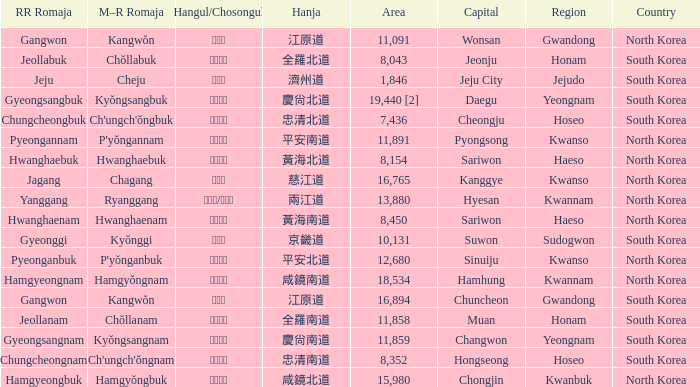What is the area for the province having Hangul of 경기도? 10131.0. 